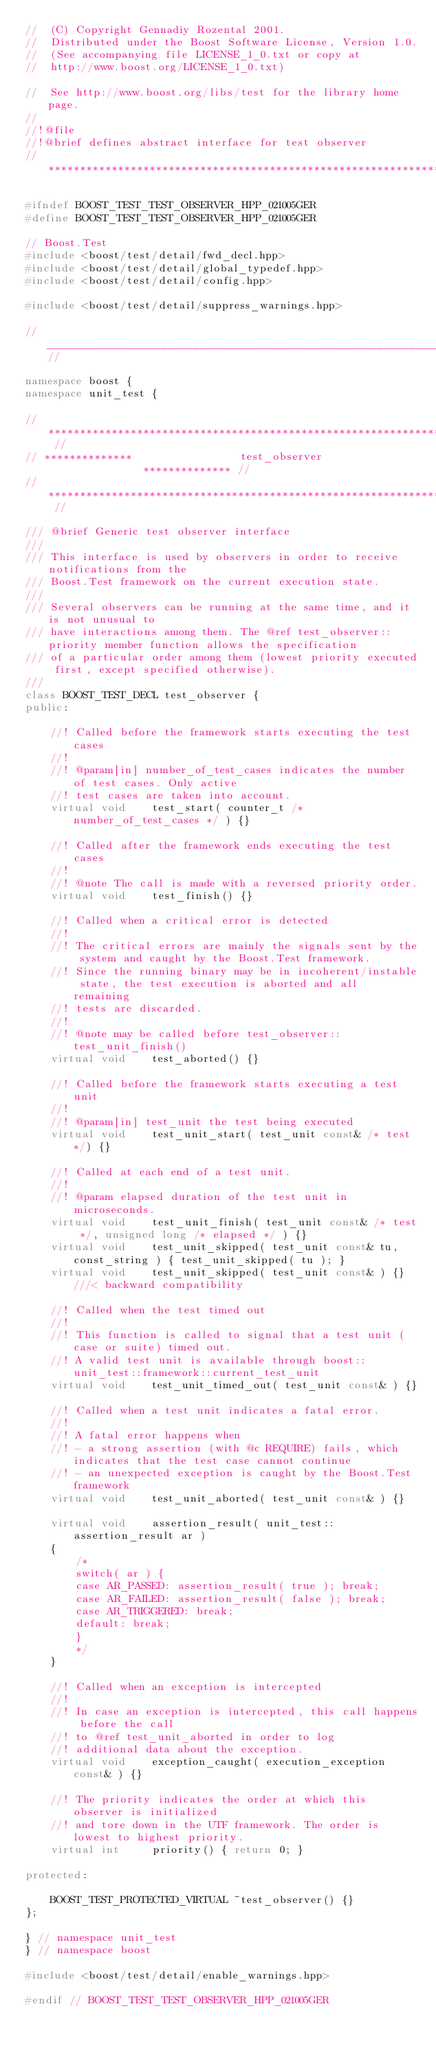<code> <loc_0><loc_0><loc_500><loc_500><_C++_>//  (C) Copyright Gennadiy Rozental 2001.
//  Distributed under the Boost Software License, Version 1.0.
//  (See accompanying file LICENSE_1_0.txt or copy at
//  http://www.boost.org/LICENSE_1_0.txt)

//  See http://www.boost.org/libs/test for the library home page.
//
//!@file
//!@brief defines abstract interface for test observer
// ***************************************************************************

#ifndef BOOST_TEST_TEST_OBSERVER_HPP_021005GER
#define BOOST_TEST_TEST_OBSERVER_HPP_021005GER

// Boost.Test
#include <boost/test/detail/fwd_decl.hpp>
#include <boost/test/detail/global_typedef.hpp>
#include <boost/test/detail/config.hpp>

#include <boost/test/detail/suppress_warnings.hpp>

//____________________________________________________________________________//

namespace boost {
namespace unit_test {

// ************************************************************************** //
// **************                 test_observer                ************** //
// ************************************************************************** //

/// @brief Generic test observer interface
///
/// This interface is used by observers in order to receive notifications from the
/// Boost.Test framework on the current execution state.
///
/// Several observers can be running at the same time, and it is not unusual to
/// have interactions among them. The @ref test_observer::priority member function allows the specification
/// of a particular order among them (lowest priority executed first, except specified otherwise).
///
class BOOST_TEST_DECL test_observer {
public:

    //! Called before the framework starts executing the test cases
    //!
    //! @param[in] number_of_test_cases indicates the number of test cases. Only active
    //! test cases are taken into account.
    virtual void    test_start( counter_t /* number_of_test_cases */ ) {}

    //! Called after the framework ends executing the test cases
    //!
    //! @note The call is made with a reversed priority order.
    virtual void    test_finish() {}

    //! Called when a critical error is detected
    //!
    //! The critical errors are mainly the signals sent by the system and caught by the Boost.Test framework.
    //! Since the running binary may be in incoherent/instable state, the test execution is aborted and all remaining
    //! tests are discarded.
    //!
    //! @note may be called before test_observer::test_unit_finish()
    virtual void    test_aborted() {}

    //! Called before the framework starts executing a test unit
    //!
    //! @param[in] test_unit the test being executed
    virtual void    test_unit_start( test_unit const& /* test */) {}

    //! Called at each end of a test unit.
    //!
    //! @param elapsed duration of the test unit in microseconds.
    virtual void    test_unit_finish( test_unit const& /* test */, unsigned long /* elapsed */ ) {}
    virtual void    test_unit_skipped( test_unit const& tu, const_string ) { test_unit_skipped( tu ); }
    virtual void    test_unit_skipped( test_unit const& ) {} ///< backward compatibility

    //! Called when the test timed out
    //!
    //! This function is called to signal that a test unit (case or suite) timed out.
    //! A valid test unit is available through boost::unit_test::framework::current_test_unit
    virtual void    test_unit_timed_out( test_unit const& ) {}

    //! Called when a test unit indicates a fatal error.
    //!
    //! A fatal error happens when
    //! - a strong assertion (with @c REQUIRE) fails, which indicates that the test case cannot continue
    //! - an unexpected exception is caught by the Boost.Test framework
    virtual void    test_unit_aborted( test_unit const& ) {}

    virtual void    assertion_result( unit_test::assertion_result ar )
    {
        /*
        switch( ar ) {
        case AR_PASSED: assertion_result( true ); break;
        case AR_FAILED: assertion_result( false ); break;
        case AR_TRIGGERED: break;
        default: break;
        }
        */
    }

    //! Called when an exception is intercepted
    //!
    //! In case an exception is intercepted, this call happens before the call
    //! to @ref test_unit_aborted in order to log
    //! additional data about the exception.
    virtual void    exception_caught( execution_exception const& ) {}

    //! The priority indicates the order at which this observer is initialized
    //! and tore down in the UTF framework. The order is lowest to highest priority.
    virtual int     priority() { return 0; }

protected:

    BOOST_TEST_PROTECTED_VIRTUAL ~test_observer() {}
};

} // namespace unit_test
} // namespace boost

#include <boost/test/detail/enable_warnings.hpp>

#endif // BOOST_TEST_TEST_OBSERVER_HPP_021005GER

</code> 